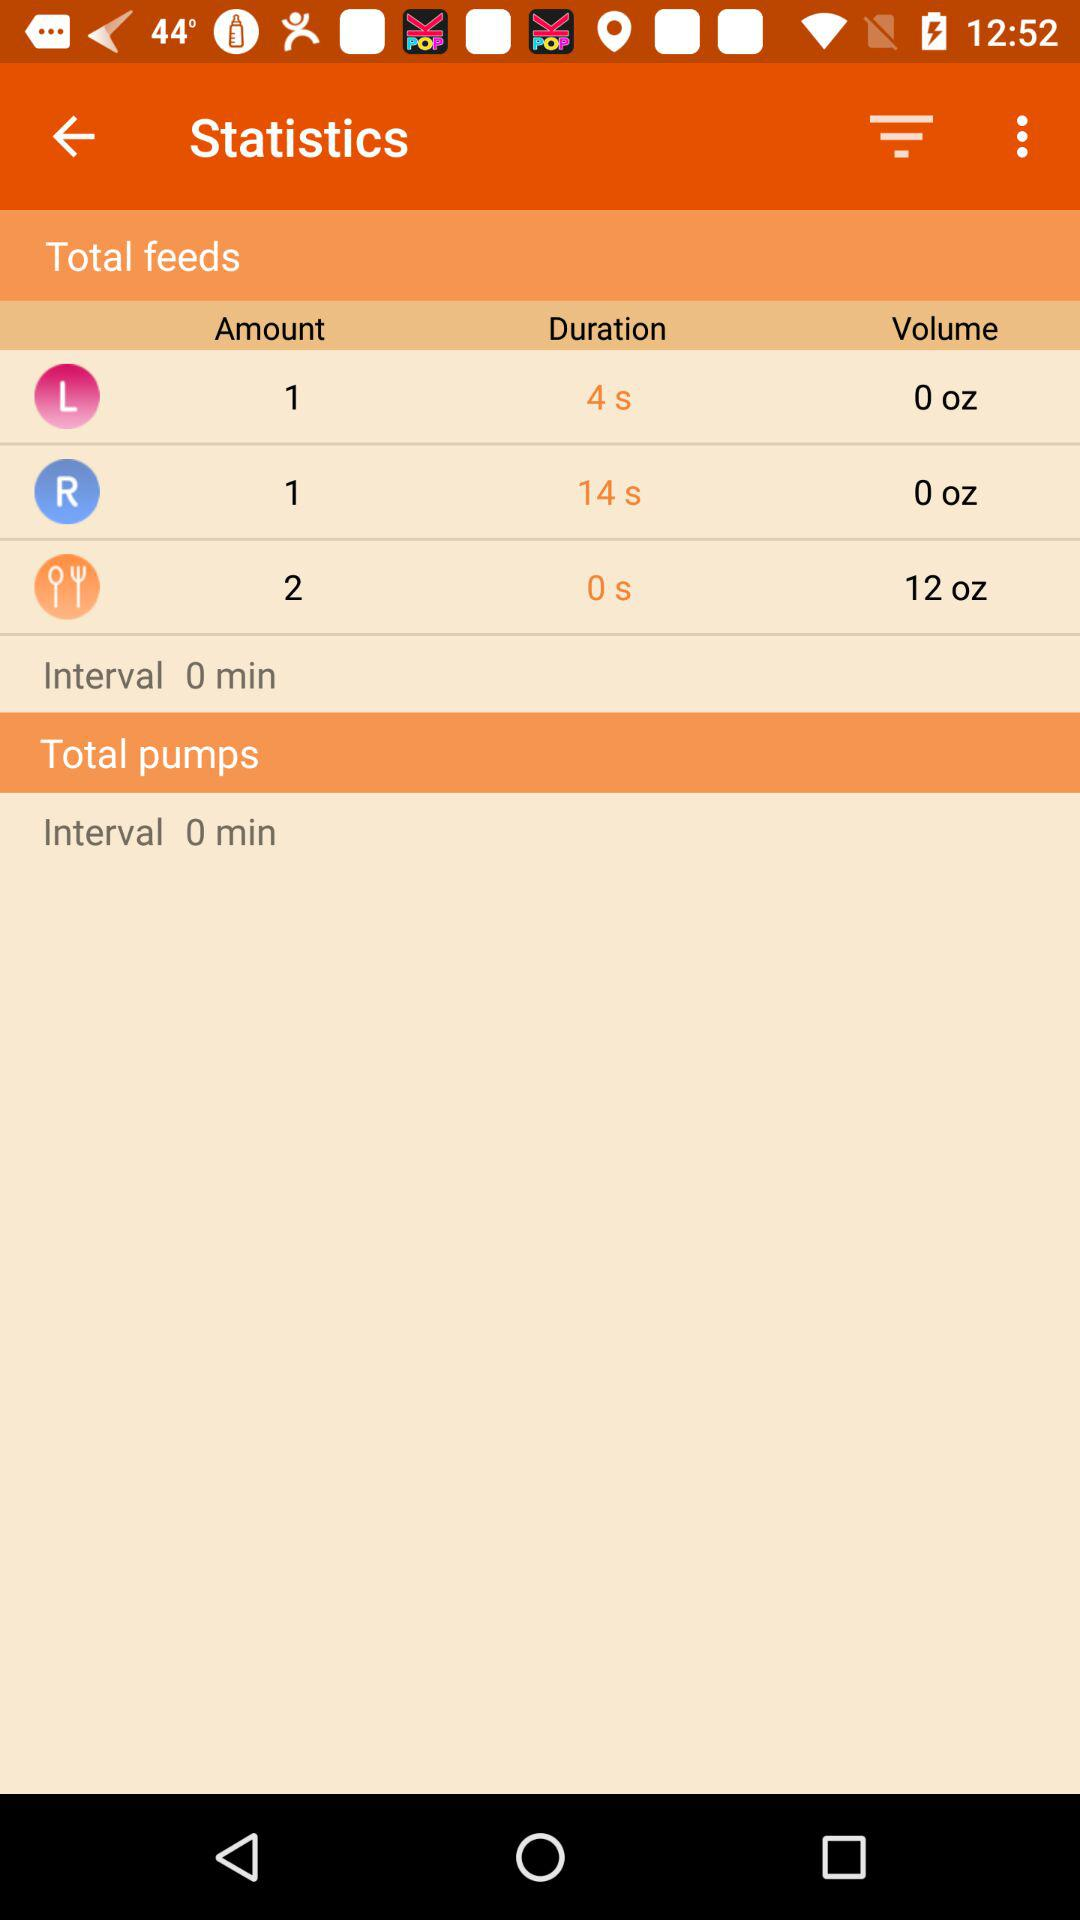How many feeds have been completed?
Answer the question using a single word or phrase. 3 